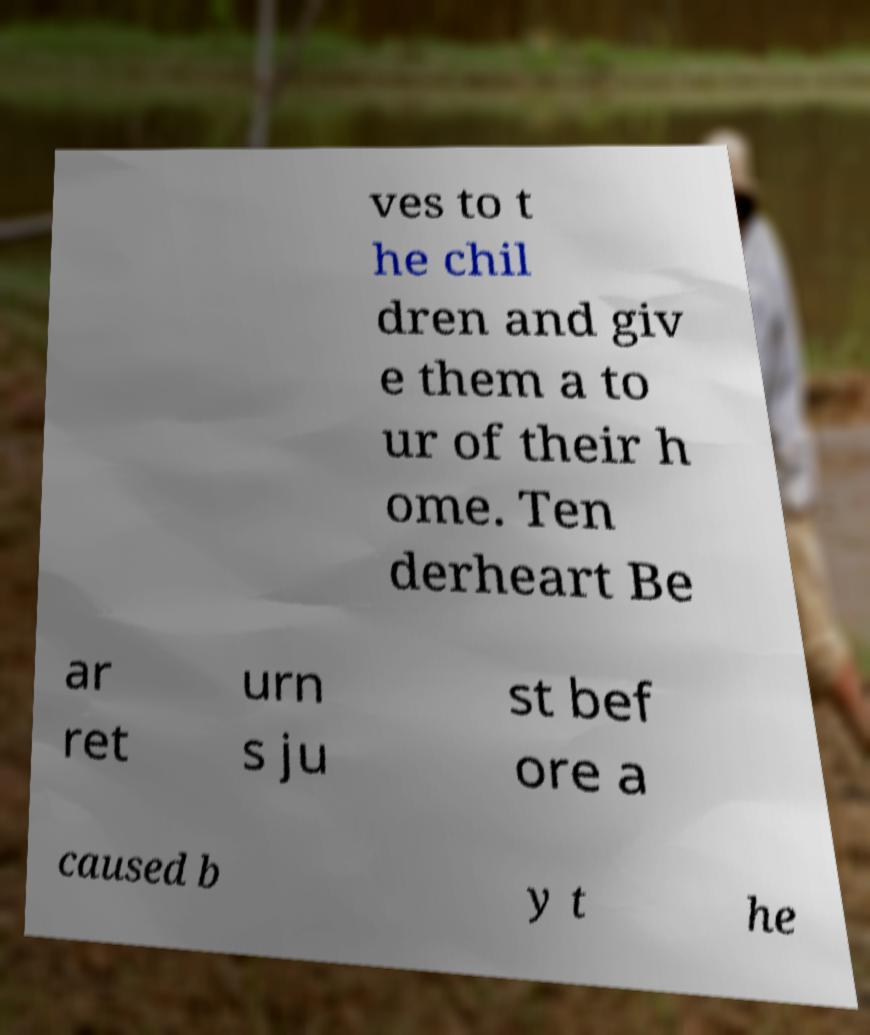Please read and relay the text visible in this image. What does it say? ves to t he chil dren and giv e them a to ur of their h ome. Ten derheart Be ar ret urn s ju st bef ore a caused b y t he 